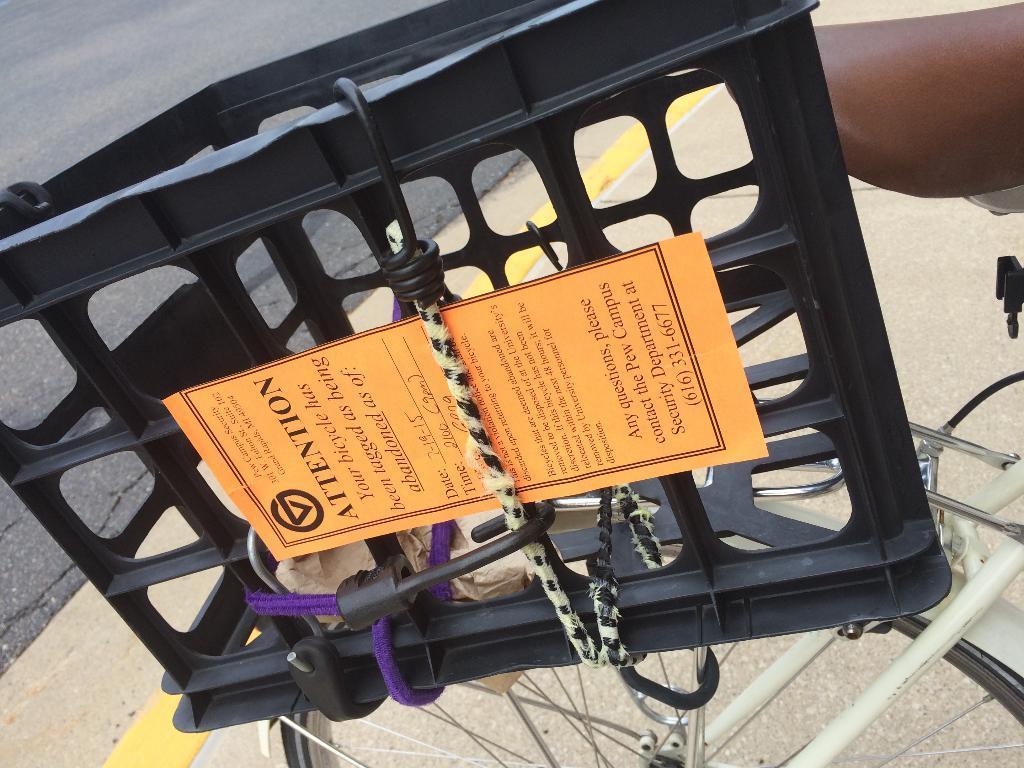In one or two sentences, can you explain what this image depicts? This is a basket, which is placed on the bicycle. I can see a paper, which is tied to the basket. In the background, I think this is a road. 